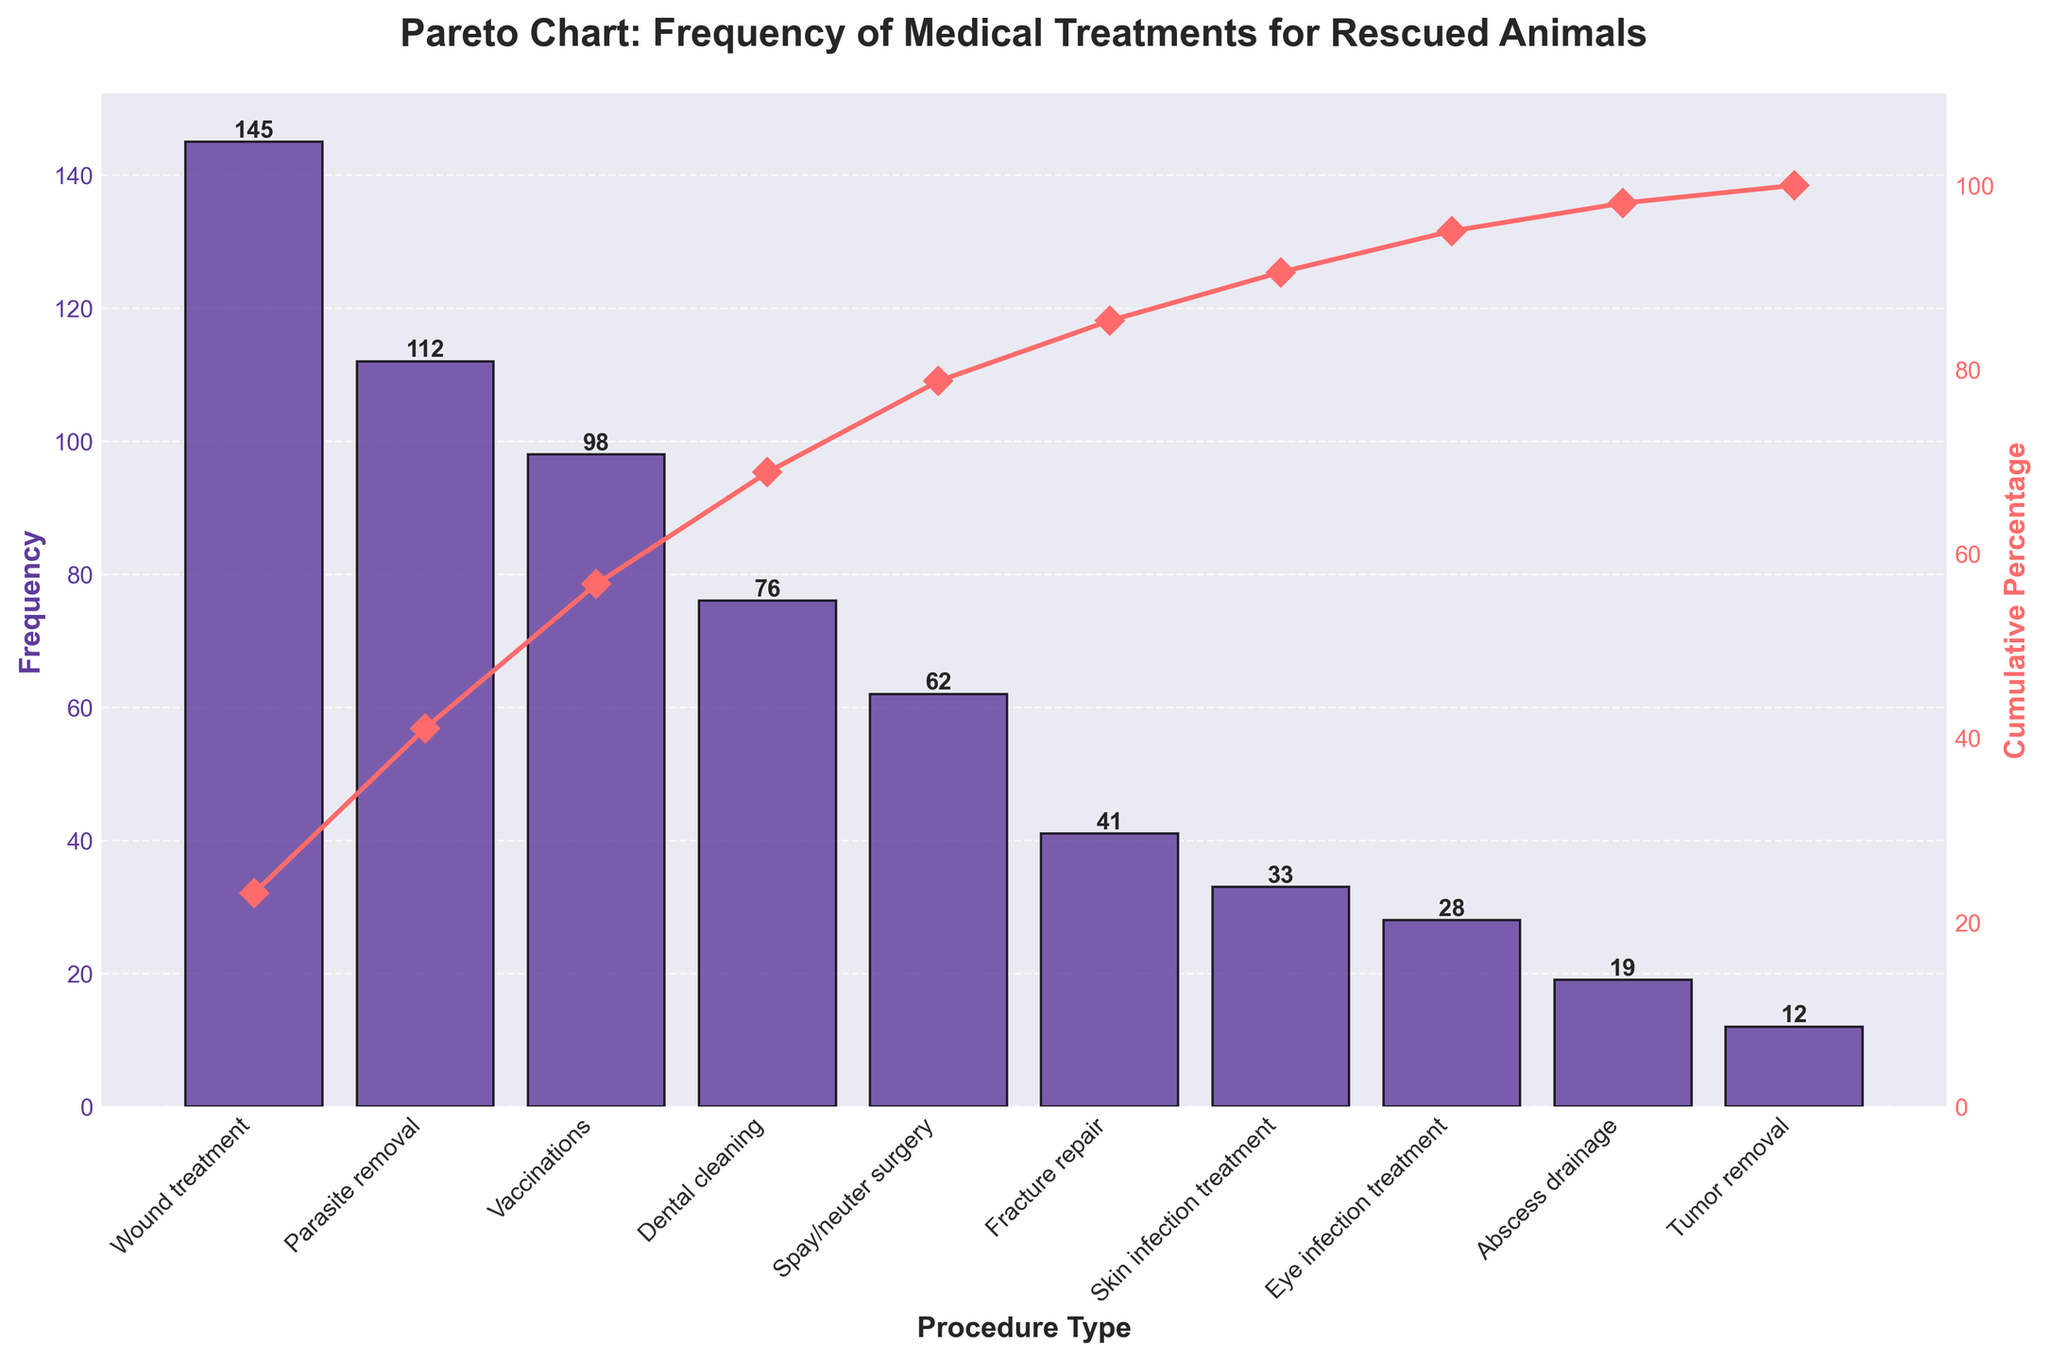What's the title of the chart? The title is usually located at the top of the chart and serves as a concise explanation of the visualized data. Here, it reads "Pareto Chart: Frequency of Medical Treatments for Rescued Animals."
Answer: Pareto Chart: Frequency of Medical Treatments for Rescued Animals What procedure has the highest frequency? The highest bar in the bar chart indicates the procedure with the highest frequency. This bar corresponds to "Wound treatment."
Answer: Wound treatment What is the frequency of vaccinations? Find the bar labeled "Vaccinations" and read its height or the number on top of it, which shows the frequency. Here it is "98."
Answer: 98 What is the cumulative percentage for parasite removal? Locate "Parasite removal" on the x-axis, then follow the corresponding cumulative percentage line to the right y-axis. It reads around "36%."
Answer: 36% How many procedures have a frequency greater than 50? Count the bars with heights above the 50 mark on the y-axis. The bars for Wound treatment, Parasite removal, Vaccinations, Dental cleaning, and Spay/neuter surgery meet this criterion.
Answer: 5 Which treatment accounts for the smallest frequency? The shortest bar in the bar chart indicates "Tumor removal," with a frequency of "12."
Answer: Tumor removal What is the cumulative percentage just before the last procedure? The procedure before the last in terms of downward order is "Abscess drainage." Its cumulative percentage can be read from the right y-axis, which is approximately "97%."
Answer: 97% Is the sum of frequencies for parasite removal and vaccinations higher than the sum for dental cleaning and spay/neuter surgery? Add the frequencies for each pair: Parasite removal (112) + Vaccinations (98) = 210; Dental cleaning (76) + Spay/neuter surgery (62) = 138. Compare the sums: 210 is greater than 138.
Answer: Yes Which two procedures contribute the most to the cumulative percentage of 60%? Starting from the highest bar, "Wound treatment" contributes around "44%," and adding the next procedure "Parasite removal" (36%) gives 44% + 36% = 80%. The cumulative percentage hits 60% within these two procedures.
Answer: Wound treatment and Parasite removal How does the frequency of fracture repair compare to eye infection treatment? Locate both bars and compare their heights or the numbers on top. Fracture repair has a frequency of "41" while Eye infection treatment has "28". Therefore, Fracture repair frequency is higher.
Answer: Higher 